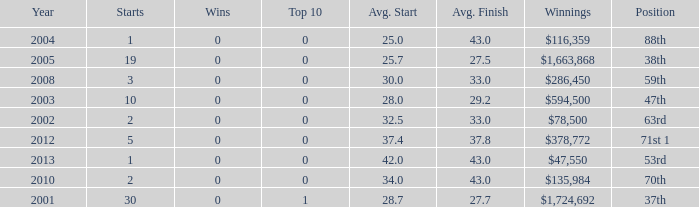What is the average top 10 score for 2 starts, winnings of $135,984 and an average finish more than 43? None. 